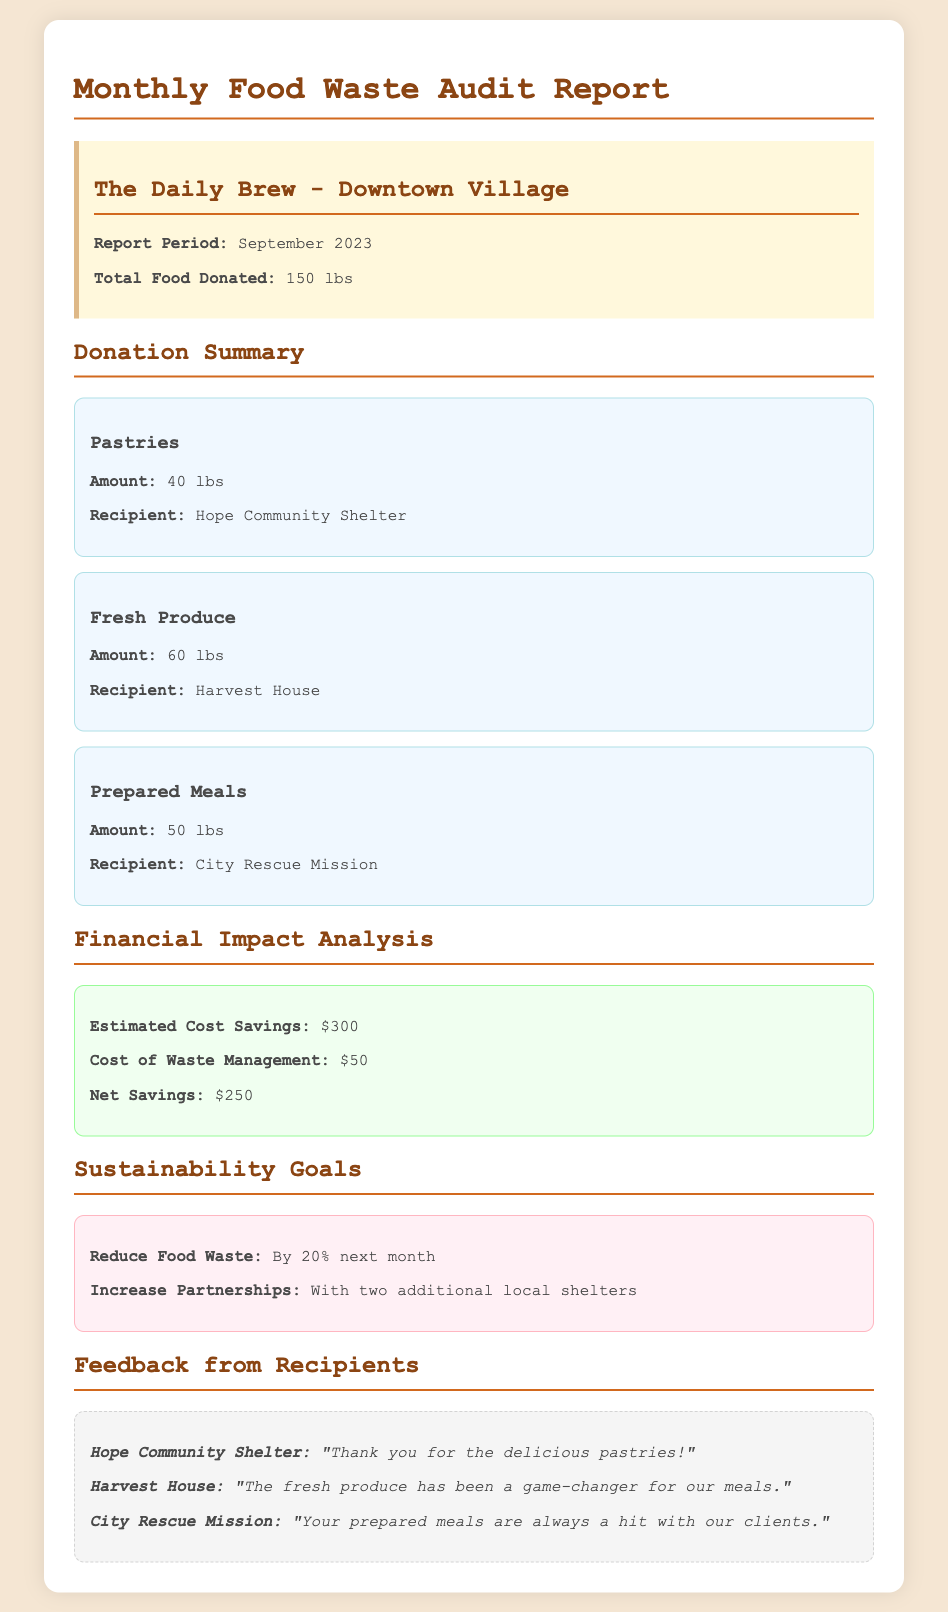What is the total food donated? The total food donated is explicitly stated in the document under the summary section as 150 lbs.
Answer: 150 lbs How much fresh produce was donated? The donation summary lists fresh produce with its amount, which is 60 lbs.
Answer: 60 lbs What is the estimated cost savings? The financial impact analysis section provides the estimated cost savings as $300.
Answer: $300 Who received the pastries? The donation summary mentions that the pastries were donated to Hope Community Shelter.
Answer: Hope Community Shelter What is the goal for reducing food waste next month? The sustainability goals section outlines the target for reducing food waste by 20%.
Answer: 20% How much was the cost of waste management? Under the financial impact analysis, the cost of waste management is listed as $50.
Answer: $50 What is the net savings from food donations? The net savings is calculated in the financial impact analysis, listed as $250.
Answer: $250 How many pounds of prepared meals were donated? The donation summary states that the amount of prepared meals donated is 50 lbs.
Answer: 50 lbs What is one feedback from City Rescue Mission? Feedback from City Rescue Mission indicates that "Your prepared meals are always a hit with our clients."
Answer: "Your prepared meals are always a hit with our clients." 